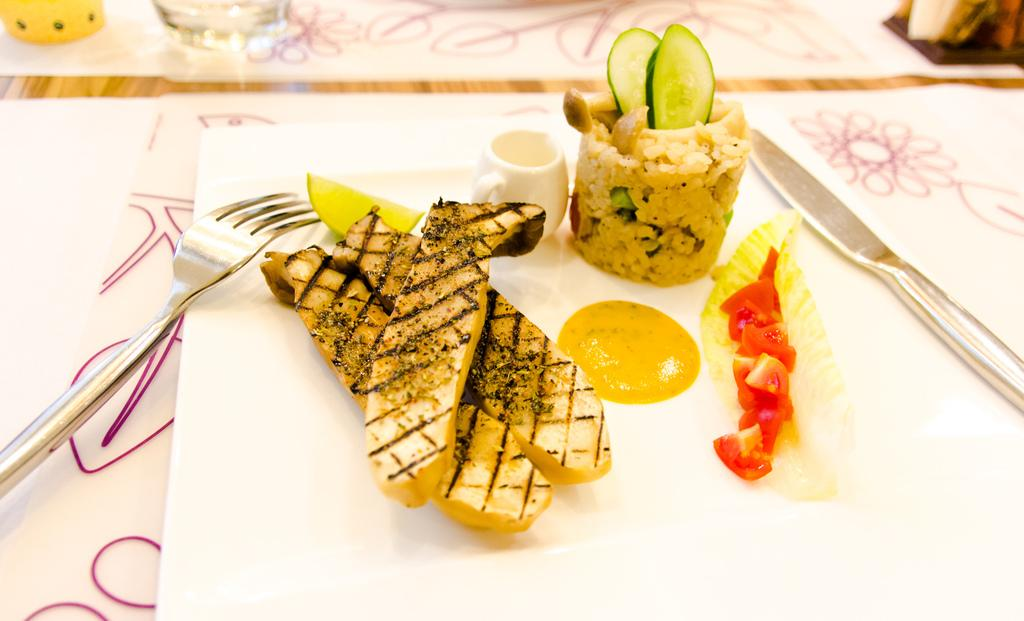What type of food can be seen on the plate in the image? There are cooked food items on a plate in the image. What utensils are present on the plate? There is a fork and a knife on the plate. What type of patch can be seen on the food in the image? There is no patch visible on the food in the image. 